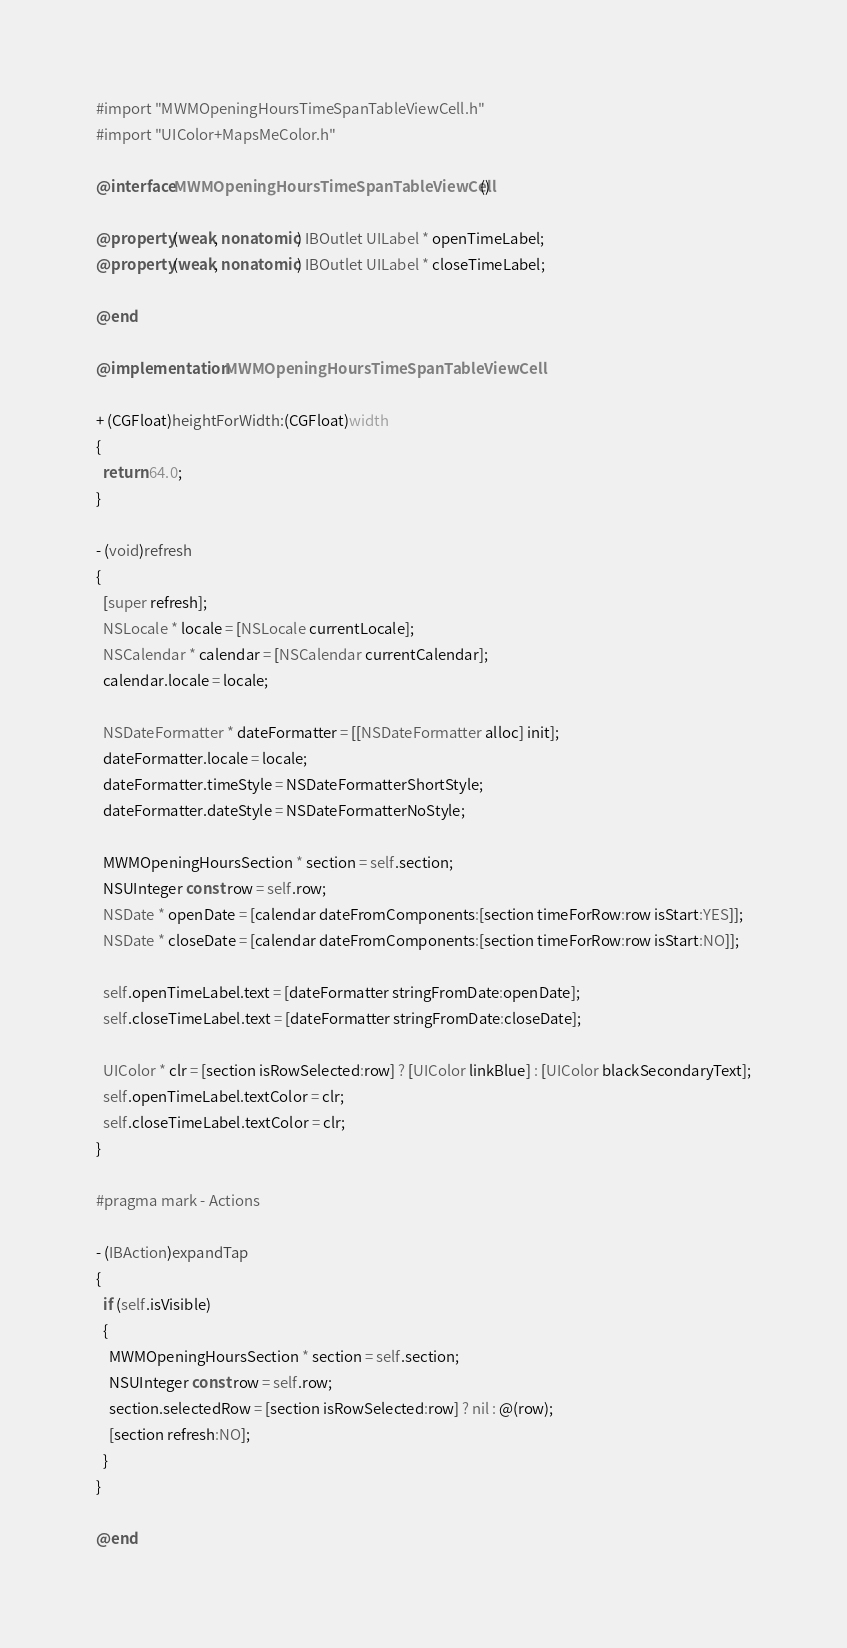Convert code to text. <code><loc_0><loc_0><loc_500><loc_500><_ObjectiveC_>#import "MWMOpeningHoursTimeSpanTableViewCell.h"
#import "UIColor+MapsMeColor.h"

@interface MWMOpeningHoursTimeSpanTableViewCell ()

@property (weak, nonatomic) IBOutlet UILabel * openTimeLabel;
@property (weak, nonatomic) IBOutlet UILabel * closeTimeLabel;

@end

@implementation MWMOpeningHoursTimeSpanTableViewCell

+ (CGFloat)heightForWidth:(CGFloat)width
{
  return 64.0;
}

- (void)refresh
{
  [super refresh];
  NSLocale * locale = [NSLocale currentLocale];
  NSCalendar * calendar = [NSCalendar currentCalendar];
  calendar.locale = locale;

  NSDateFormatter * dateFormatter = [[NSDateFormatter alloc] init];
  dateFormatter.locale = locale;
  dateFormatter.timeStyle = NSDateFormatterShortStyle;
  dateFormatter.dateStyle = NSDateFormatterNoStyle;

  MWMOpeningHoursSection * section = self.section;
  NSUInteger const row = self.row;
  NSDate * openDate = [calendar dateFromComponents:[section timeForRow:row isStart:YES]];
  NSDate * closeDate = [calendar dateFromComponents:[section timeForRow:row isStart:NO]];

  self.openTimeLabel.text = [dateFormatter stringFromDate:openDate];
  self.closeTimeLabel.text = [dateFormatter stringFromDate:closeDate];

  UIColor * clr = [section isRowSelected:row] ? [UIColor linkBlue] : [UIColor blackSecondaryText];
  self.openTimeLabel.textColor = clr;
  self.closeTimeLabel.textColor = clr;
}

#pragma mark - Actions

- (IBAction)expandTap
{
  if (self.isVisible)
  {
    MWMOpeningHoursSection * section = self.section;
    NSUInteger const row = self.row;
    section.selectedRow = [section isRowSelected:row] ? nil : @(row);
    [section refresh:NO];
  }
}

@end
</code> 